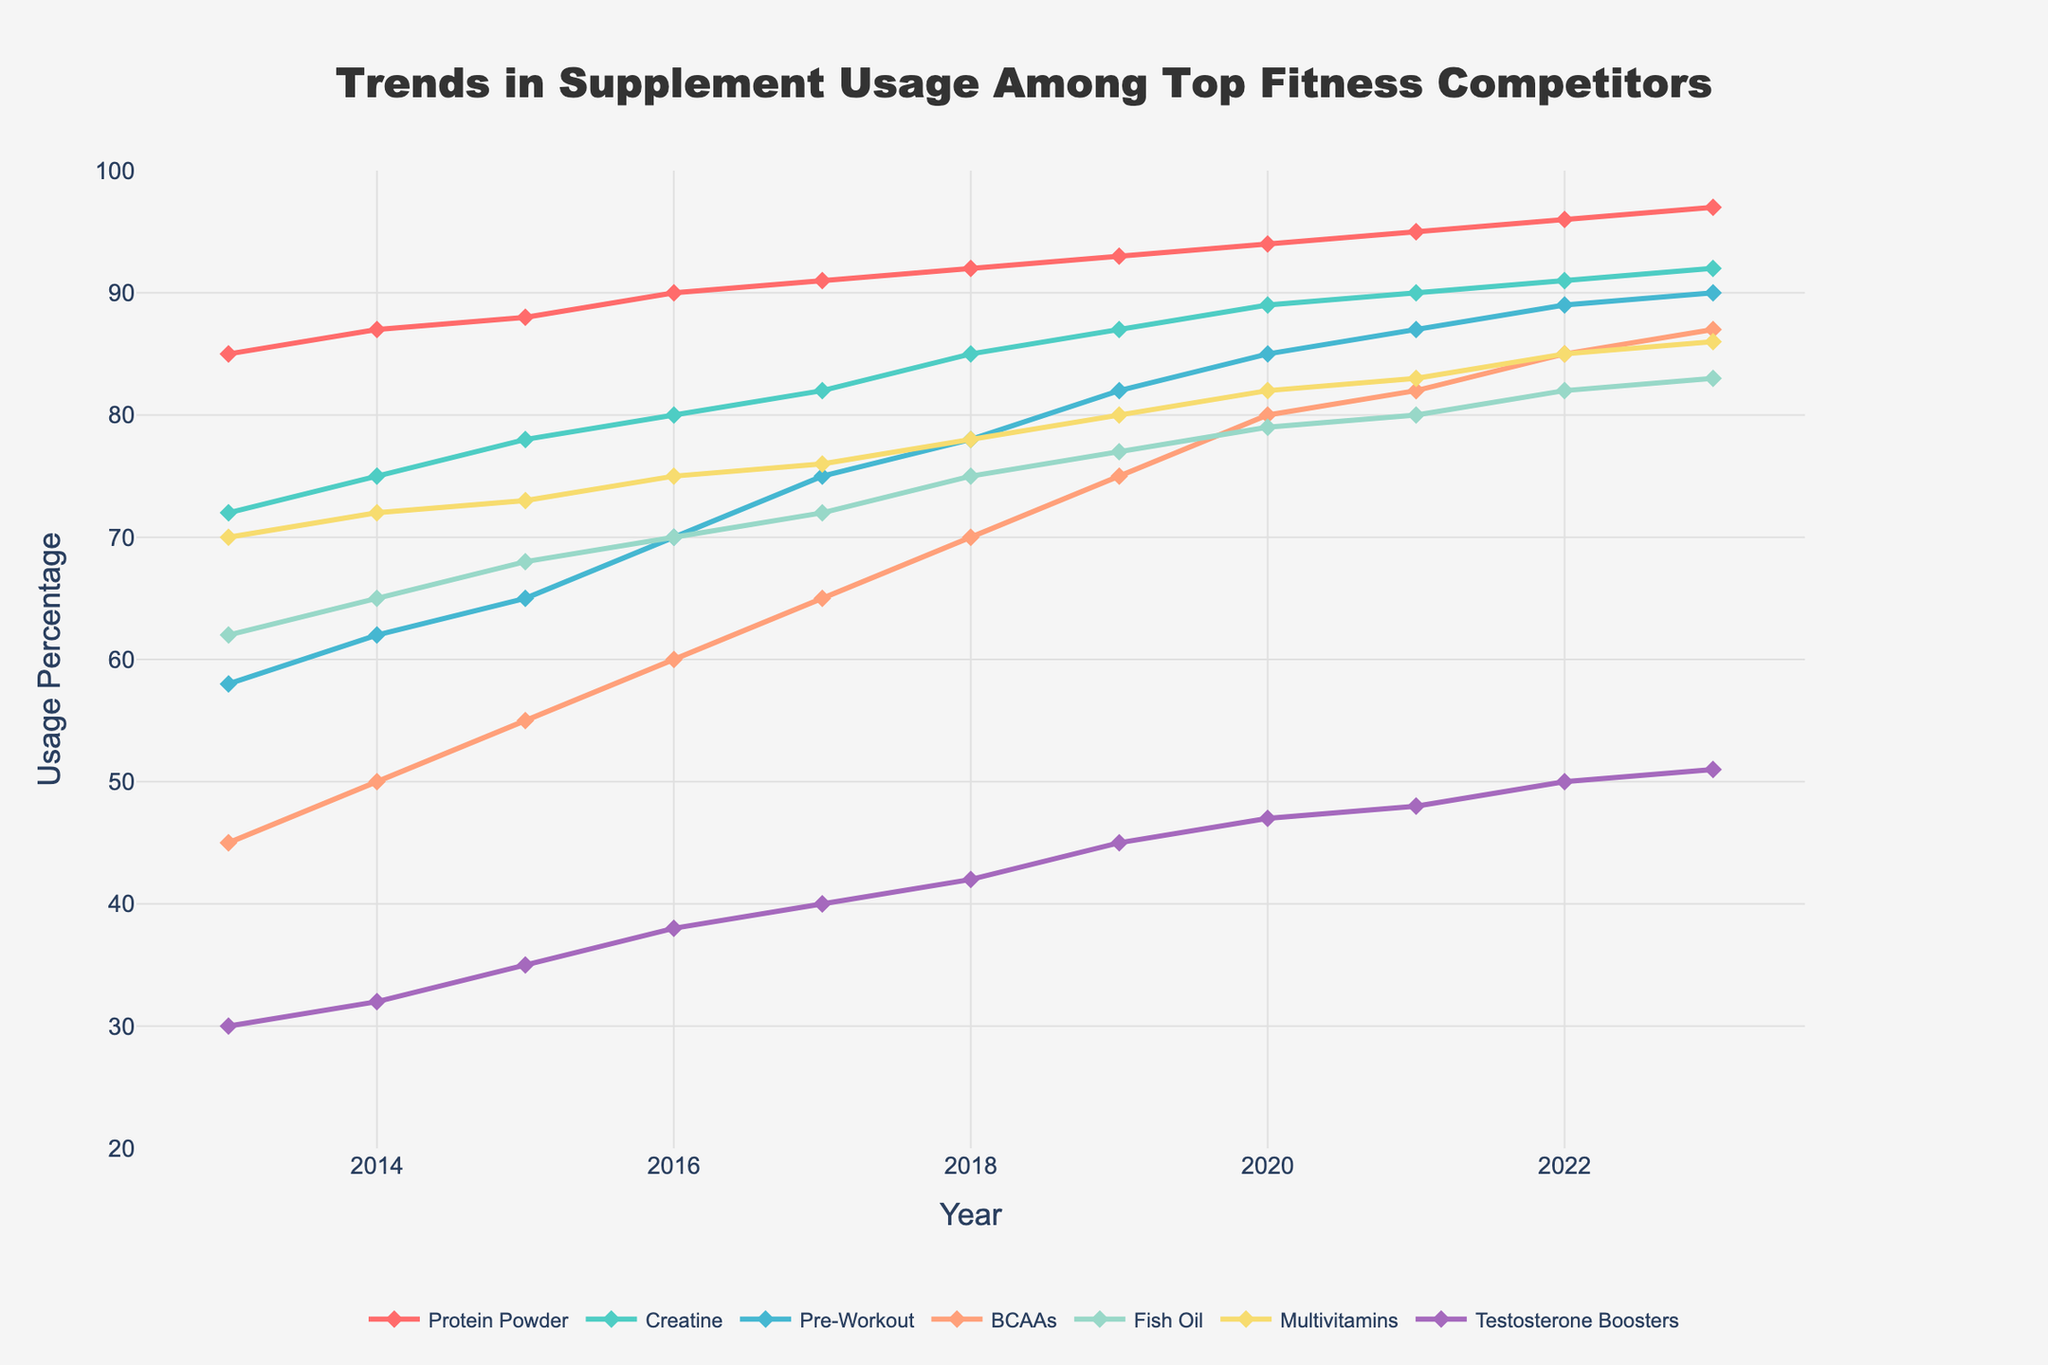What was the percentage increase in Protein Powder usage from 2013 to 2023? The Protein Powder usage in 2013 was 85%, and in 2023 it was 97%. The increase is calculated as (97 - 85) / 85 * 100%.
Answer: 14.12% Which supplement had the lowest usage in 2013, and what was its percentage? By comparing the values of each supplement in 2013, Testosterone Boosters had the lowest usage at 30%.
Answer: Testosterone Boosters at 30% In which year did BCAAs usage first surpass 50%? Looking at the trend line for BCAAs, the usage surpasses 50% between 2014 and 2015, specifically reaching 55% in 2015.
Answer: 2015 Compare the trends between Creatine and Fish Oil from 2015 to 2020. Which showed a higher overall increase in percentage usage? From 2015 to 2020, Creatine usage increased from 78% to 89%, a 11% increase. Fish Oil increased from 68% to 79%, which is an 11% increase too. Both have the same increase of 11%.
Answer: Both have same increase What is the average usage percentage of Multivitamins from 2015 to 2023? Sum the percentages of Multivitamins from 2015 to 2023 and divide by the number of years. (73+75+76+78+80+82+83+85+86)/9 = 82.
Answer: 82% Which year showed the highest annual increase in Pre-Workout usage? Check the year-to-year increase for Pre-Workout between 2013 and 2023. The highest increase is from 2020 to 2021, where it went from 85% to 87%, a 2% increase.
Answer: 2021 Does Fish Oil or Multivitamins have a steeper incline in usage between 2013 and 2023? For Fish Oil, usage increased from 62% to 83%, a difference of 21%. For Multivitamins, usage increased from 70% to 86%, a difference of 16%. Fish Oil has a steeper incline.
Answer: Fish Oil By how much did Testosterone Boosters’ usage change from 2013 to 2023? Testosterone Boosters' usage changed from 30% in 2013 to 51% in 2023. The change is 51 - 30 = 21%.
Answer: 21% Which supplement had consistent growth every year from 2013 to 2023? Checking each supplement, Protein Powder showed consistent growth every year.
Answer: Protein Powder By 2023, which supplement has the closest usage percentage to BCAAs? In 2023, BCAAs are at 87%. The closest is Pre-Workout at 90%.
Answer: Pre-Workout 